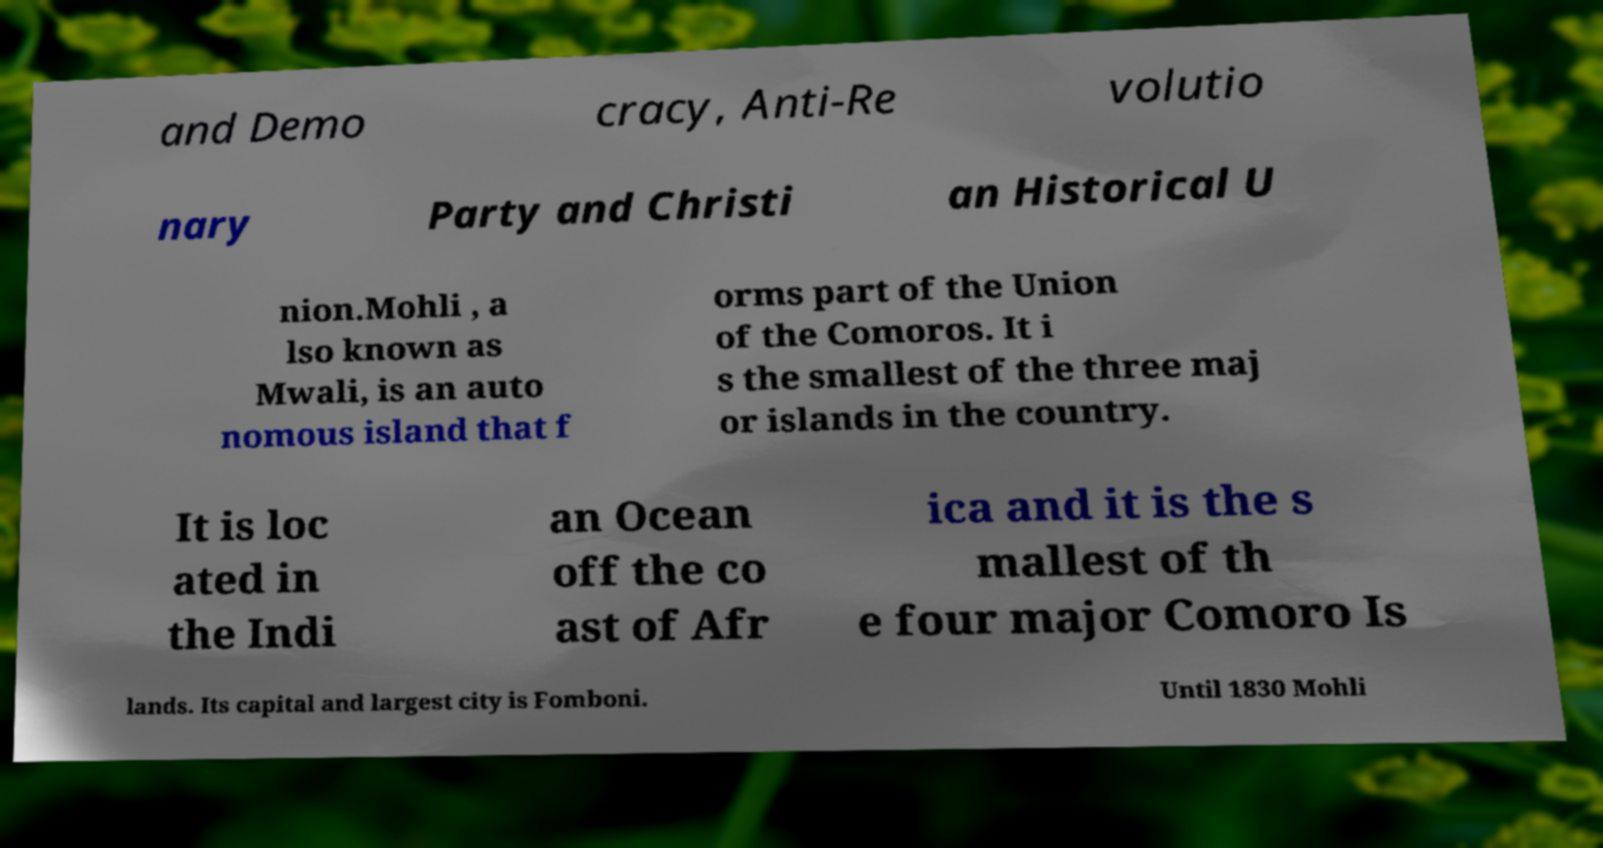For documentation purposes, I need the text within this image transcribed. Could you provide that? and Demo cracy, Anti-Re volutio nary Party and Christi an Historical U nion.Mohli , a lso known as Mwali, is an auto nomous island that f orms part of the Union of the Comoros. It i s the smallest of the three maj or islands in the country. It is loc ated in the Indi an Ocean off the co ast of Afr ica and it is the s mallest of th e four major Comoro Is lands. Its capital and largest city is Fomboni. Until 1830 Mohli 